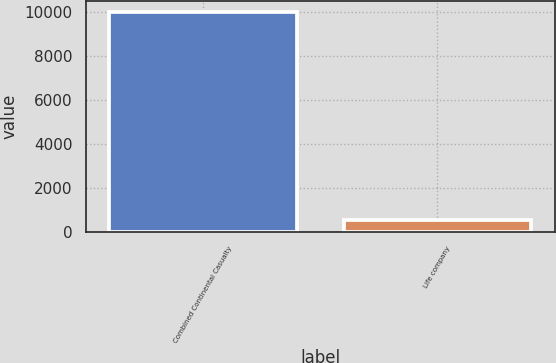Convert chart to OTSL. <chart><loc_0><loc_0><loc_500><loc_500><bar_chart><fcel>Combined Continental Casualty<fcel>Life company<nl><fcel>9998<fcel>556<nl></chart> 